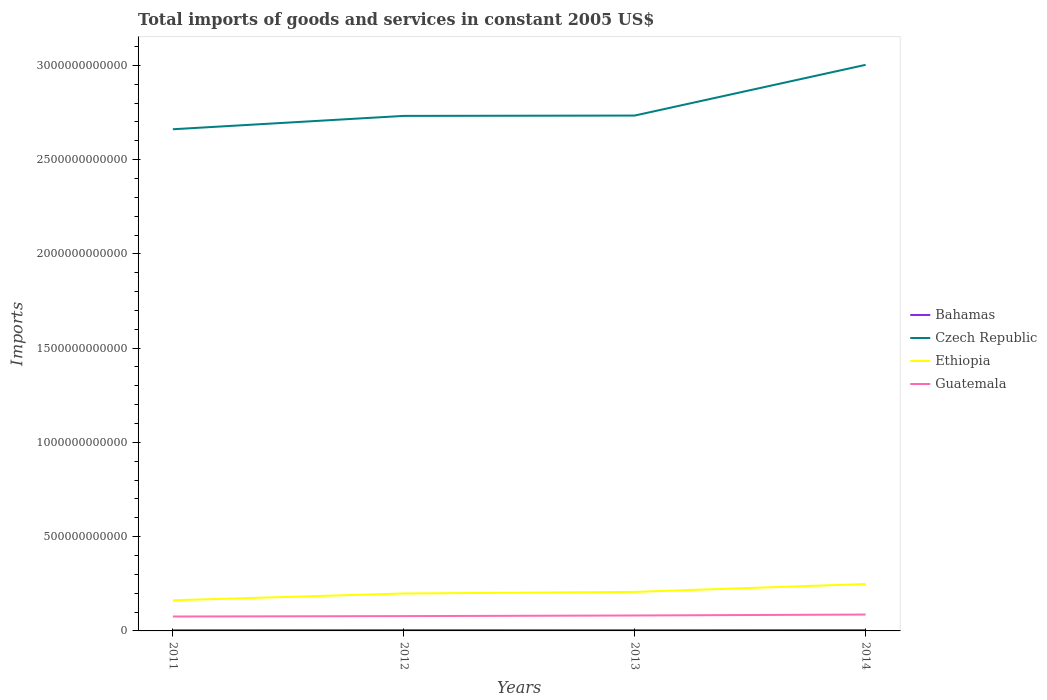Does the line corresponding to Czech Republic intersect with the line corresponding to Guatemala?
Give a very brief answer. No. Is the number of lines equal to the number of legend labels?
Ensure brevity in your answer.  Yes. Across all years, what is the maximum total imports of goods and services in Guatemala?
Offer a very short reply. 7.64e+1. In which year was the total imports of goods and services in Czech Republic maximum?
Your answer should be compact. 2011. What is the total total imports of goods and services in Bahamas in the graph?
Your answer should be compact. -3.73e+08. What is the difference between the highest and the second highest total imports of goods and services in Bahamas?
Ensure brevity in your answer.  5.74e+08. What is the difference between the highest and the lowest total imports of goods and services in Czech Republic?
Give a very brief answer. 1. Is the total imports of goods and services in Bahamas strictly greater than the total imports of goods and services in Guatemala over the years?
Your response must be concise. Yes. How many lines are there?
Provide a short and direct response. 4. How many years are there in the graph?
Your response must be concise. 4. What is the difference between two consecutive major ticks on the Y-axis?
Provide a short and direct response. 5.00e+11. Are the values on the major ticks of Y-axis written in scientific E-notation?
Offer a terse response. No. Where does the legend appear in the graph?
Give a very brief answer. Center right. How many legend labels are there?
Your answer should be compact. 4. How are the legend labels stacked?
Offer a very short reply. Vertical. What is the title of the graph?
Provide a succinct answer. Total imports of goods and services in constant 2005 US$. Does "Montenegro" appear as one of the legend labels in the graph?
Provide a short and direct response. No. What is the label or title of the Y-axis?
Ensure brevity in your answer.  Imports. What is the Imports in Bahamas in 2011?
Your answer should be compact. 3.76e+09. What is the Imports of Czech Republic in 2011?
Offer a terse response. 2.66e+12. What is the Imports in Ethiopia in 2011?
Your answer should be very brief. 1.62e+11. What is the Imports of Guatemala in 2011?
Your answer should be very brief. 7.64e+1. What is the Imports in Bahamas in 2012?
Ensure brevity in your answer.  4.14e+09. What is the Imports in Czech Republic in 2012?
Give a very brief answer. 2.73e+12. What is the Imports in Ethiopia in 2012?
Provide a short and direct response. 1.99e+11. What is the Imports of Guatemala in 2012?
Ensure brevity in your answer.  7.86e+1. What is the Imports in Bahamas in 2013?
Offer a very short reply. 3.91e+09. What is the Imports of Czech Republic in 2013?
Your answer should be compact. 2.73e+12. What is the Imports of Ethiopia in 2013?
Make the answer very short. 2.07e+11. What is the Imports in Guatemala in 2013?
Your answer should be compact. 8.19e+1. What is the Imports in Bahamas in 2014?
Make the answer very short. 4.34e+09. What is the Imports in Czech Republic in 2014?
Make the answer very short. 3.00e+12. What is the Imports of Ethiopia in 2014?
Keep it short and to the point. 2.49e+11. What is the Imports of Guatemala in 2014?
Provide a short and direct response. 8.68e+1. Across all years, what is the maximum Imports in Bahamas?
Your answer should be very brief. 4.34e+09. Across all years, what is the maximum Imports of Czech Republic?
Your response must be concise. 3.00e+12. Across all years, what is the maximum Imports of Ethiopia?
Make the answer very short. 2.49e+11. Across all years, what is the maximum Imports in Guatemala?
Your response must be concise. 8.68e+1. Across all years, what is the minimum Imports of Bahamas?
Offer a very short reply. 3.76e+09. Across all years, what is the minimum Imports in Czech Republic?
Your answer should be very brief. 2.66e+12. Across all years, what is the minimum Imports in Ethiopia?
Your answer should be very brief. 1.62e+11. Across all years, what is the minimum Imports in Guatemala?
Your answer should be compact. 7.64e+1. What is the total Imports of Bahamas in the graph?
Your response must be concise. 1.61e+1. What is the total Imports in Czech Republic in the graph?
Give a very brief answer. 1.11e+13. What is the total Imports in Ethiopia in the graph?
Your answer should be very brief. 8.17e+11. What is the total Imports in Guatemala in the graph?
Offer a very short reply. 3.24e+11. What is the difference between the Imports of Bahamas in 2011 and that in 2012?
Provide a short and direct response. -3.73e+08. What is the difference between the Imports in Czech Republic in 2011 and that in 2012?
Your answer should be very brief. -7.08e+1. What is the difference between the Imports of Ethiopia in 2011 and that in 2012?
Offer a terse response. -3.61e+1. What is the difference between the Imports of Guatemala in 2011 and that in 2012?
Provide a short and direct response. -2.13e+09. What is the difference between the Imports of Bahamas in 2011 and that in 2013?
Ensure brevity in your answer.  -1.52e+08. What is the difference between the Imports in Czech Republic in 2011 and that in 2013?
Give a very brief answer. -7.26e+1. What is the difference between the Imports in Ethiopia in 2011 and that in 2013?
Offer a very short reply. -4.44e+1. What is the difference between the Imports of Guatemala in 2011 and that in 2013?
Your answer should be very brief. -5.48e+09. What is the difference between the Imports of Bahamas in 2011 and that in 2014?
Your response must be concise. -5.74e+08. What is the difference between the Imports in Czech Republic in 2011 and that in 2014?
Your response must be concise. -3.42e+11. What is the difference between the Imports in Ethiopia in 2011 and that in 2014?
Your response must be concise. -8.62e+1. What is the difference between the Imports of Guatemala in 2011 and that in 2014?
Give a very brief answer. -1.04e+1. What is the difference between the Imports in Bahamas in 2012 and that in 2013?
Make the answer very short. 2.21e+08. What is the difference between the Imports in Czech Republic in 2012 and that in 2013?
Keep it short and to the point. -1.78e+09. What is the difference between the Imports of Ethiopia in 2012 and that in 2013?
Ensure brevity in your answer.  -8.37e+09. What is the difference between the Imports in Guatemala in 2012 and that in 2013?
Your answer should be very brief. -3.35e+09. What is the difference between the Imports of Bahamas in 2012 and that in 2014?
Your response must be concise. -2.02e+08. What is the difference between the Imports in Czech Republic in 2012 and that in 2014?
Keep it short and to the point. -2.71e+11. What is the difference between the Imports in Ethiopia in 2012 and that in 2014?
Your answer should be very brief. -5.01e+1. What is the difference between the Imports in Guatemala in 2012 and that in 2014?
Your answer should be very brief. -8.27e+09. What is the difference between the Imports in Bahamas in 2013 and that in 2014?
Ensure brevity in your answer.  -4.23e+08. What is the difference between the Imports in Czech Republic in 2013 and that in 2014?
Provide a short and direct response. -2.69e+11. What is the difference between the Imports of Ethiopia in 2013 and that in 2014?
Give a very brief answer. -4.18e+1. What is the difference between the Imports in Guatemala in 2013 and that in 2014?
Your response must be concise. -4.92e+09. What is the difference between the Imports of Bahamas in 2011 and the Imports of Czech Republic in 2012?
Make the answer very short. -2.73e+12. What is the difference between the Imports of Bahamas in 2011 and the Imports of Ethiopia in 2012?
Provide a succinct answer. -1.95e+11. What is the difference between the Imports of Bahamas in 2011 and the Imports of Guatemala in 2012?
Ensure brevity in your answer.  -7.48e+1. What is the difference between the Imports of Czech Republic in 2011 and the Imports of Ethiopia in 2012?
Ensure brevity in your answer.  2.46e+12. What is the difference between the Imports in Czech Republic in 2011 and the Imports in Guatemala in 2012?
Your answer should be very brief. 2.58e+12. What is the difference between the Imports in Ethiopia in 2011 and the Imports in Guatemala in 2012?
Give a very brief answer. 8.39e+1. What is the difference between the Imports in Bahamas in 2011 and the Imports in Czech Republic in 2013?
Your answer should be very brief. -2.73e+12. What is the difference between the Imports of Bahamas in 2011 and the Imports of Ethiopia in 2013?
Provide a succinct answer. -2.03e+11. What is the difference between the Imports of Bahamas in 2011 and the Imports of Guatemala in 2013?
Offer a terse response. -7.81e+1. What is the difference between the Imports of Czech Republic in 2011 and the Imports of Ethiopia in 2013?
Your answer should be very brief. 2.45e+12. What is the difference between the Imports in Czech Republic in 2011 and the Imports in Guatemala in 2013?
Ensure brevity in your answer.  2.58e+12. What is the difference between the Imports in Ethiopia in 2011 and the Imports in Guatemala in 2013?
Keep it short and to the point. 8.06e+1. What is the difference between the Imports of Bahamas in 2011 and the Imports of Czech Republic in 2014?
Offer a very short reply. -3.00e+12. What is the difference between the Imports in Bahamas in 2011 and the Imports in Ethiopia in 2014?
Your answer should be very brief. -2.45e+11. What is the difference between the Imports in Bahamas in 2011 and the Imports in Guatemala in 2014?
Ensure brevity in your answer.  -8.31e+1. What is the difference between the Imports of Czech Republic in 2011 and the Imports of Ethiopia in 2014?
Give a very brief answer. 2.41e+12. What is the difference between the Imports of Czech Republic in 2011 and the Imports of Guatemala in 2014?
Give a very brief answer. 2.57e+12. What is the difference between the Imports in Ethiopia in 2011 and the Imports in Guatemala in 2014?
Give a very brief answer. 7.57e+1. What is the difference between the Imports in Bahamas in 2012 and the Imports in Czech Republic in 2013?
Your answer should be very brief. -2.73e+12. What is the difference between the Imports of Bahamas in 2012 and the Imports of Ethiopia in 2013?
Ensure brevity in your answer.  -2.03e+11. What is the difference between the Imports in Bahamas in 2012 and the Imports in Guatemala in 2013?
Ensure brevity in your answer.  -7.78e+1. What is the difference between the Imports of Czech Republic in 2012 and the Imports of Ethiopia in 2013?
Provide a succinct answer. 2.52e+12. What is the difference between the Imports in Czech Republic in 2012 and the Imports in Guatemala in 2013?
Provide a succinct answer. 2.65e+12. What is the difference between the Imports of Ethiopia in 2012 and the Imports of Guatemala in 2013?
Your answer should be very brief. 1.17e+11. What is the difference between the Imports of Bahamas in 2012 and the Imports of Czech Republic in 2014?
Give a very brief answer. -3.00e+12. What is the difference between the Imports of Bahamas in 2012 and the Imports of Ethiopia in 2014?
Make the answer very short. -2.45e+11. What is the difference between the Imports in Bahamas in 2012 and the Imports in Guatemala in 2014?
Offer a terse response. -8.27e+1. What is the difference between the Imports of Czech Republic in 2012 and the Imports of Ethiopia in 2014?
Provide a succinct answer. 2.48e+12. What is the difference between the Imports in Czech Republic in 2012 and the Imports in Guatemala in 2014?
Make the answer very short. 2.64e+12. What is the difference between the Imports in Ethiopia in 2012 and the Imports in Guatemala in 2014?
Provide a succinct answer. 1.12e+11. What is the difference between the Imports of Bahamas in 2013 and the Imports of Czech Republic in 2014?
Ensure brevity in your answer.  -3.00e+12. What is the difference between the Imports of Bahamas in 2013 and the Imports of Ethiopia in 2014?
Your response must be concise. -2.45e+11. What is the difference between the Imports in Bahamas in 2013 and the Imports in Guatemala in 2014?
Your response must be concise. -8.29e+1. What is the difference between the Imports of Czech Republic in 2013 and the Imports of Ethiopia in 2014?
Provide a succinct answer. 2.48e+12. What is the difference between the Imports of Czech Republic in 2013 and the Imports of Guatemala in 2014?
Offer a terse response. 2.65e+12. What is the difference between the Imports of Ethiopia in 2013 and the Imports of Guatemala in 2014?
Keep it short and to the point. 1.20e+11. What is the average Imports in Bahamas per year?
Your answer should be very brief. 4.04e+09. What is the average Imports of Czech Republic per year?
Offer a very short reply. 2.78e+12. What is the average Imports in Ethiopia per year?
Ensure brevity in your answer.  2.04e+11. What is the average Imports in Guatemala per year?
Offer a very short reply. 8.09e+1. In the year 2011, what is the difference between the Imports of Bahamas and Imports of Czech Republic?
Your answer should be very brief. -2.66e+12. In the year 2011, what is the difference between the Imports of Bahamas and Imports of Ethiopia?
Offer a very short reply. -1.59e+11. In the year 2011, what is the difference between the Imports of Bahamas and Imports of Guatemala?
Your answer should be compact. -7.27e+1. In the year 2011, what is the difference between the Imports of Czech Republic and Imports of Ethiopia?
Offer a terse response. 2.50e+12. In the year 2011, what is the difference between the Imports in Czech Republic and Imports in Guatemala?
Your response must be concise. 2.58e+12. In the year 2011, what is the difference between the Imports of Ethiopia and Imports of Guatemala?
Your response must be concise. 8.61e+1. In the year 2012, what is the difference between the Imports of Bahamas and Imports of Czech Republic?
Keep it short and to the point. -2.73e+12. In the year 2012, what is the difference between the Imports of Bahamas and Imports of Ethiopia?
Provide a short and direct response. -1.94e+11. In the year 2012, what is the difference between the Imports in Bahamas and Imports in Guatemala?
Your answer should be very brief. -7.44e+1. In the year 2012, what is the difference between the Imports in Czech Republic and Imports in Ethiopia?
Your response must be concise. 2.53e+12. In the year 2012, what is the difference between the Imports in Czech Republic and Imports in Guatemala?
Your response must be concise. 2.65e+12. In the year 2012, what is the difference between the Imports in Ethiopia and Imports in Guatemala?
Make the answer very short. 1.20e+11. In the year 2013, what is the difference between the Imports of Bahamas and Imports of Czech Republic?
Offer a terse response. -2.73e+12. In the year 2013, what is the difference between the Imports in Bahamas and Imports in Ethiopia?
Your answer should be very brief. -2.03e+11. In the year 2013, what is the difference between the Imports in Bahamas and Imports in Guatemala?
Ensure brevity in your answer.  -7.80e+1. In the year 2013, what is the difference between the Imports in Czech Republic and Imports in Ethiopia?
Provide a succinct answer. 2.53e+12. In the year 2013, what is the difference between the Imports of Czech Republic and Imports of Guatemala?
Give a very brief answer. 2.65e+12. In the year 2013, what is the difference between the Imports in Ethiopia and Imports in Guatemala?
Make the answer very short. 1.25e+11. In the year 2014, what is the difference between the Imports in Bahamas and Imports in Czech Republic?
Give a very brief answer. -3.00e+12. In the year 2014, what is the difference between the Imports in Bahamas and Imports in Ethiopia?
Give a very brief answer. -2.44e+11. In the year 2014, what is the difference between the Imports of Bahamas and Imports of Guatemala?
Your answer should be compact. -8.25e+1. In the year 2014, what is the difference between the Imports of Czech Republic and Imports of Ethiopia?
Offer a very short reply. 2.75e+12. In the year 2014, what is the difference between the Imports of Czech Republic and Imports of Guatemala?
Keep it short and to the point. 2.92e+12. In the year 2014, what is the difference between the Imports of Ethiopia and Imports of Guatemala?
Ensure brevity in your answer.  1.62e+11. What is the ratio of the Imports of Bahamas in 2011 to that in 2012?
Provide a short and direct response. 0.91. What is the ratio of the Imports of Czech Republic in 2011 to that in 2012?
Provide a short and direct response. 0.97. What is the ratio of the Imports of Ethiopia in 2011 to that in 2012?
Ensure brevity in your answer.  0.82. What is the ratio of the Imports of Guatemala in 2011 to that in 2012?
Ensure brevity in your answer.  0.97. What is the ratio of the Imports in Bahamas in 2011 to that in 2013?
Provide a short and direct response. 0.96. What is the ratio of the Imports of Czech Republic in 2011 to that in 2013?
Provide a short and direct response. 0.97. What is the ratio of the Imports in Ethiopia in 2011 to that in 2013?
Offer a very short reply. 0.79. What is the ratio of the Imports of Guatemala in 2011 to that in 2013?
Make the answer very short. 0.93. What is the ratio of the Imports in Bahamas in 2011 to that in 2014?
Ensure brevity in your answer.  0.87. What is the ratio of the Imports in Czech Republic in 2011 to that in 2014?
Offer a very short reply. 0.89. What is the ratio of the Imports in Ethiopia in 2011 to that in 2014?
Keep it short and to the point. 0.65. What is the ratio of the Imports of Guatemala in 2011 to that in 2014?
Offer a terse response. 0.88. What is the ratio of the Imports of Bahamas in 2012 to that in 2013?
Offer a terse response. 1.06. What is the ratio of the Imports in Czech Republic in 2012 to that in 2013?
Keep it short and to the point. 1. What is the ratio of the Imports in Ethiopia in 2012 to that in 2013?
Make the answer very short. 0.96. What is the ratio of the Imports in Guatemala in 2012 to that in 2013?
Offer a terse response. 0.96. What is the ratio of the Imports in Bahamas in 2012 to that in 2014?
Your response must be concise. 0.95. What is the ratio of the Imports of Czech Republic in 2012 to that in 2014?
Offer a terse response. 0.91. What is the ratio of the Imports of Ethiopia in 2012 to that in 2014?
Make the answer very short. 0.8. What is the ratio of the Imports in Guatemala in 2012 to that in 2014?
Offer a terse response. 0.9. What is the ratio of the Imports in Bahamas in 2013 to that in 2014?
Offer a very short reply. 0.9. What is the ratio of the Imports of Czech Republic in 2013 to that in 2014?
Give a very brief answer. 0.91. What is the ratio of the Imports of Ethiopia in 2013 to that in 2014?
Provide a short and direct response. 0.83. What is the ratio of the Imports in Guatemala in 2013 to that in 2014?
Offer a very short reply. 0.94. What is the difference between the highest and the second highest Imports in Bahamas?
Your response must be concise. 2.02e+08. What is the difference between the highest and the second highest Imports of Czech Republic?
Your answer should be very brief. 2.69e+11. What is the difference between the highest and the second highest Imports in Ethiopia?
Ensure brevity in your answer.  4.18e+1. What is the difference between the highest and the second highest Imports in Guatemala?
Your response must be concise. 4.92e+09. What is the difference between the highest and the lowest Imports in Bahamas?
Your answer should be very brief. 5.74e+08. What is the difference between the highest and the lowest Imports of Czech Republic?
Your answer should be very brief. 3.42e+11. What is the difference between the highest and the lowest Imports in Ethiopia?
Offer a terse response. 8.62e+1. What is the difference between the highest and the lowest Imports of Guatemala?
Your answer should be compact. 1.04e+1. 